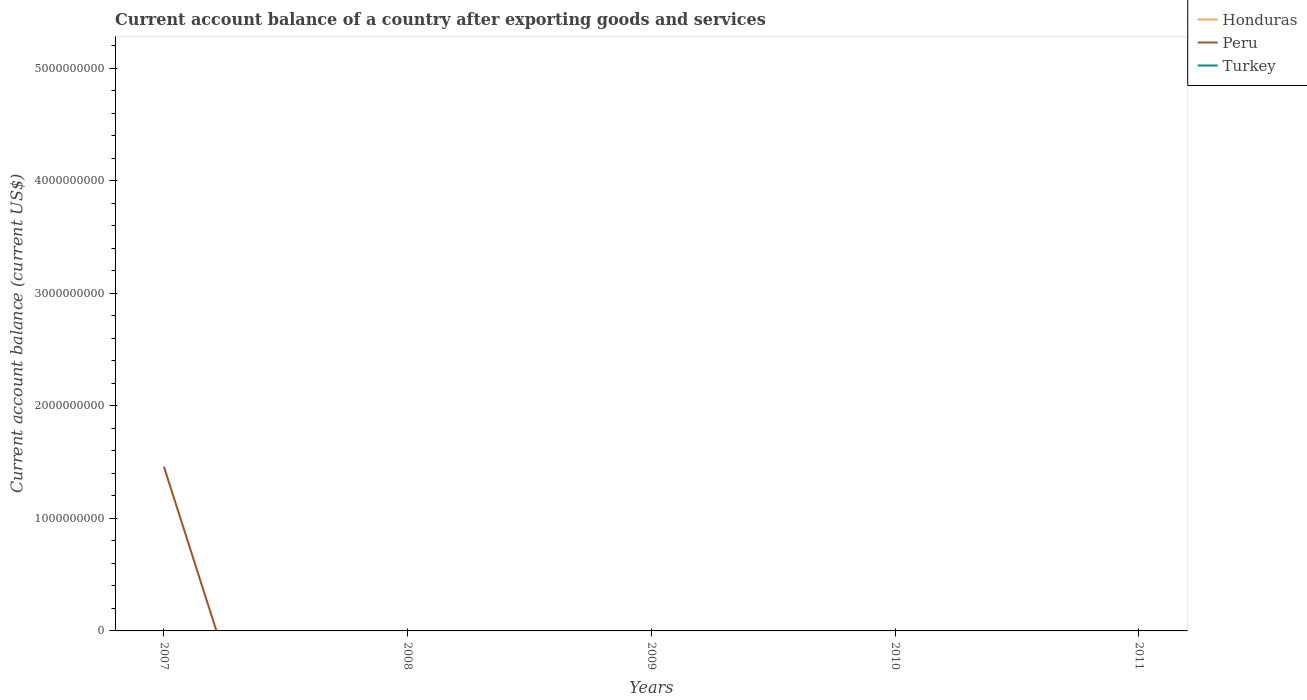How many different coloured lines are there?
Offer a terse response. 1. What is the difference between the highest and the second highest account balance in Peru?
Give a very brief answer. 1.46e+09. Are the values on the major ticks of Y-axis written in scientific E-notation?
Provide a succinct answer. No. How many legend labels are there?
Your answer should be very brief. 3. How are the legend labels stacked?
Provide a succinct answer. Vertical. What is the title of the graph?
Offer a terse response. Current account balance of a country after exporting goods and services. Does "Germany" appear as one of the legend labels in the graph?
Provide a short and direct response. No. What is the label or title of the Y-axis?
Provide a short and direct response. Current account balance (current US$). What is the Current account balance (current US$) in Honduras in 2007?
Give a very brief answer. 0. What is the Current account balance (current US$) in Peru in 2007?
Make the answer very short. 1.46e+09. What is the Current account balance (current US$) in Honduras in 2009?
Give a very brief answer. 0. What is the Current account balance (current US$) in Turkey in 2009?
Offer a terse response. 0. What is the Current account balance (current US$) in Peru in 2010?
Give a very brief answer. 0. What is the Current account balance (current US$) in Turkey in 2010?
Ensure brevity in your answer.  0. What is the Current account balance (current US$) in Peru in 2011?
Your answer should be very brief. 0. What is the Current account balance (current US$) of Turkey in 2011?
Your response must be concise. 0. Across all years, what is the maximum Current account balance (current US$) of Peru?
Keep it short and to the point. 1.46e+09. What is the total Current account balance (current US$) in Peru in the graph?
Provide a short and direct response. 1.46e+09. What is the total Current account balance (current US$) in Turkey in the graph?
Offer a terse response. 0. What is the average Current account balance (current US$) in Honduras per year?
Offer a very short reply. 0. What is the average Current account balance (current US$) in Peru per year?
Ensure brevity in your answer.  2.92e+08. What is the average Current account balance (current US$) in Turkey per year?
Your answer should be compact. 0. What is the difference between the highest and the lowest Current account balance (current US$) of Peru?
Give a very brief answer. 1.46e+09. 